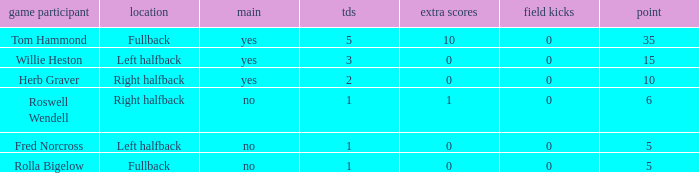How many extra points did right halfback Roswell Wendell have? 1.0. 